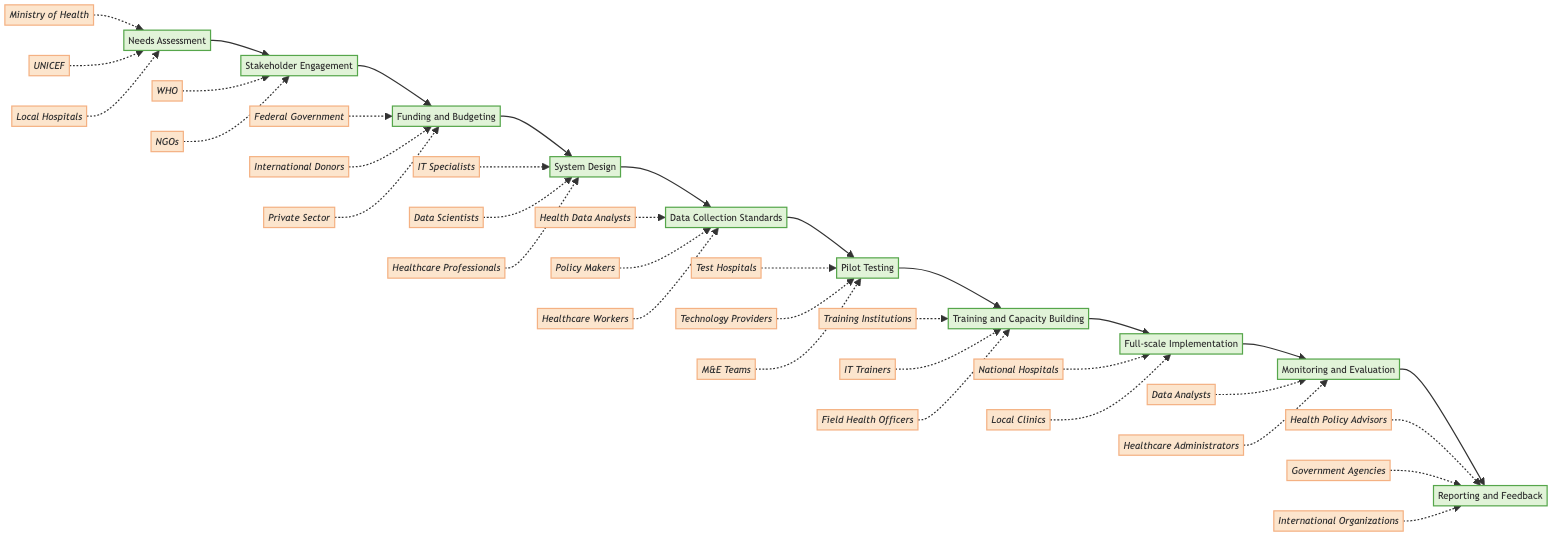What is the first step in the process? The first step in the process, indicated at the beginning of the flowchart, is "Needs Assessment."
Answer: Needs Assessment How many nodes are in the diagram? By counting each labeled step in the flowchart, we find there are ten nodes in total.
Answer: Ten What stakeholder is associated with "Funding and Budgeting"? The stakeholders connected to "Funding and Budgeting" include the Federal Government, International Donors, and the Private Sector; one example is the Federal Government.
Answer: Federal Government What follows "Pilot Testing" in the process? In the flowchart, the next step after "Pilot Testing" is "Training and Capacity Building," as indicated by the arrow leading to it.
Answer: Training and Capacity Building Which stakeholders are involved in "Monitoring and Evaluation"? The stakeholders involved in "Monitoring and Evaluation" are Data Analysts, Healthcare Administrators, and Policy Makers; one key stakeholder is Data Analysts.
Answer: Data Analysts What is the relationship between "System Design" and "Data Collection Standards"? "System Design" precedes "Data Collection Standards," meaning "System Design" leads to "Data Collection Standards" in the sequence of steps.
Answer: Precedes How many stakeholders are associated with the "Needs Assessment"? The "Needs Assessment" has three listed stakeholders, which are the Ministry of Health, UNICEF, and Local Hospitals.
Answer: Three Which step occurs before "Full-scale Implementation"? The step that occurs directly before "Full-scale Implementation" is "Training and Capacity Building," as seen in the flow of the diagram.
Answer: Training and Capacity Building What is the last step in the process? The final step of the process outlined in the flowchart is "Reporting and Feedback," indicated at the end of the sequence.
Answer: Reporting and Feedback Which organization is involved in "Stakeholder Engagement"? In "Stakeholder Engagement," one notable organization involved is the World Health Organization, among others.
Answer: World Health Organization 